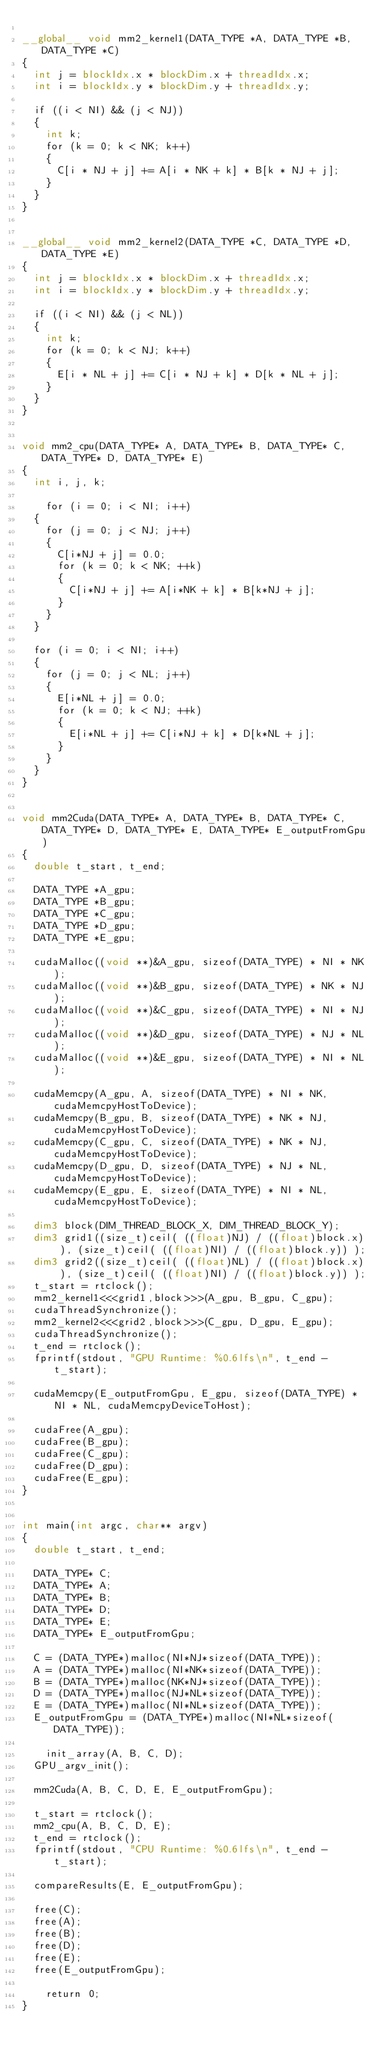Convert code to text. <code><loc_0><loc_0><loc_500><loc_500><_Cuda_>
__global__ void mm2_kernel1(DATA_TYPE *A, DATA_TYPE *B, DATA_TYPE *C)
{
	int j = blockIdx.x * blockDim.x + threadIdx.x;
	int i = blockIdx.y * blockDim.y + threadIdx.y;

	if ((i < NI) && (j < NJ))
	{ 
		int k;
		for (k = 0; k < NK; k++)
		{
			C[i * NJ + j] += A[i * NK + k] * B[k * NJ + j];
		}
	}
}


__global__ void mm2_kernel2(DATA_TYPE *C, DATA_TYPE *D, DATA_TYPE *E)
{
	int j = blockIdx.x * blockDim.x + threadIdx.x;
	int i = blockIdx.y * blockDim.y + threadIdx.y;

	if ((i < NI) && (j < NL))
	{ 
		int k;
		for (k = 0; k < NJ; k++)
		{
			E[i * NL + j] += C[i * NJ + k] * D[k * NL + j];
		}
	}
}


void mm2_cpu(DATA_TYPE* A, DATA_TYPE* B, DATA_TYPE* C, DATA_TYPE* D, DATA_TYPE* E)
{
	int i, j, k;
	
  	for (i = 0; i < NI; i++)
	{
		for (j = 0; j < NJ; j++)
		{
			C[i*NJ + j] = 0.0;
			for (k = 0; k < NK; ++k)
			{
				C[i*NJ + j] += A[i*NK + k] * B[k*NJ + j];
			}
		}
	}
	
	for (i = 0; i < NI; i++)
	{
		for (j = 0; j < NL; j++)
		{
			E[i*NL + j] = 0.0;
			for (k = 0; k < NJ; ++k)
			{
				E[i*NL + j] += C[i*NJ + k] * D[k*NL + j];
			}
		}
	}
}


void mm2Cuda(DATA_TYPE* A, DATA_TYPE* B, DATA_TYPE* C, DATA_TYPE* D, DATA_TYPE* E, DATA_TYPE* E_outputFromGpu)
{
	double t_start, t_end;

	DATA_TYPE *A_gpu;
	DATA_TYPE *B_gpu;
	DATA_TYPE *C_gpu;
	DATA_TYPE *D_gpu;
	DATA_TYPE *E_gpu;

	cudaMalloc((void **)&A_gpu, sizeof(DATA_TYPE) * NI * NK);
	cudaMalloc((void **)&B_gpu, sizeof(DATA_TYPE) * NK * NJ);
	cudaMalloc((void **)&C_gpu, sizeof(DATA_TYPE) * NI * NJ);
	cudaMalloc((void **)&D_gpu, sizeof(DATA_TYPE) * NJ * NL);
	cudaMalloc((void **)&E_gpu, sizeof(DATA_TYPE) * NI * NL);
	
	cudaMemcpy(A_gpu, A, sizeof(DATA_TYPE) * NI * NK, cudaMemcpyHostToDevice);
	cudaMemcpy(B_gpu, B, sizeof(DATA_TYPE) * NK * NJ, cudaMemcpyHostToDevice);
	cudaMemcpy(C_gpu, C, sizeof(DATA_TYPE) * NK * NJ, cudaMemcpyHostToDevice);
	cudaMemcpy(D_gpu, D, sizeof(DATA_TYPE) * NJ * NL, cudaMemcpyHostToDevice);
	cudaMemcpy(E_gpu, E, sizeof(DATA_TYPE) * NI * NL, cudaMemcpyHostToDevice);	
		
	dim3 block(DIM_THREAD_BLOCK_X, DIM_THREAD_BLOCK_Y);
	dim3 grid1((size_t)ceil( ((float)NJ) / ((float)block.x) ), (size_t)ceil( ((float)NI) / ((float)block.y)) );
	dim3 grid2((size_t)ceil( ((float)NL) / ((float)block.x) ), (size_t)ceil( ((float)NI) / ((float)block.y)) );
	t_start = rtclock();
	mm2_kernel1<<<grid1,block>>>(A_gpu, B_gpu, C_gpu);
	cudaThreadSynchronize();
	mm2_kernel2<<<grid2,block>>>(C_gpu, D_gpu, E_gpu);
	cudaThreadSynchronize();
	t_end = rtclock();
	fprintf(stdout, "GPU Runtime: %0.6lfs\n", t_end - t_start);

	cudaMemcpy(E_outputFromGpu, E_gpu, sizeof(DATA_TYPE) * NI * NL, cudaMemcpyDeviceToHost);

	cudaFree(A_gpu);
	cudaFree(B_gpu);
	cudaFree(C_gpu);
	cudaFree(D_gpu);
	cudaFree(E_gpu);
}


int main(int argc, char** argv)
{
	double t_start, t_end;
	
	DATA_TYPE* C;
	DATA_TYPE* A;
	DATA_TYPE* B;
	DATA_TYPE* D;
	DATA_TYPE* E;
	DATA_TYPE* E_outputFromGpu;

	C = (DATA_TYPE*)malloc(NI*NJ*sizeof(DATA_TYPE));
	A = (DATA_TYPE*)malloc(NI*NK*sizeof(DATA_TYPE));
	B = (DATA_TYPE*)malloc(NK*NJ*sizeof(DATA_TYPE));
	D = (DATA_TYPE*)malloc(NJ*NL*sizeof(DATA_TYPE));
	E = (DATA_TYPE*)malloc(NI*NL*sizeof(DATA_TYPE));
	E_outputFromGpu = (DATA_TYPE*)malloc(NI*NL*sizeof(DATA_TYPE));

  	init_array(A, B, C, D);
	GPU_argv_init();

	mm2Cuda(A, B, C, D, E, E_outputFromGpu);

	t_start = rtclock();
	mm2_cpu(A, B, C, D, E);
	t_end = rtclock();
	fprintf(stdout, "CPU Runtime: %0.6lfs\n", t_end - t_start);

	compareResults(E, E_outputFromGpu);

	free(C);
	free(A);
	free(B);
	free(D);
	free(E);
	free(E_outputFromGpu);

  	return 0;
}

</code> 